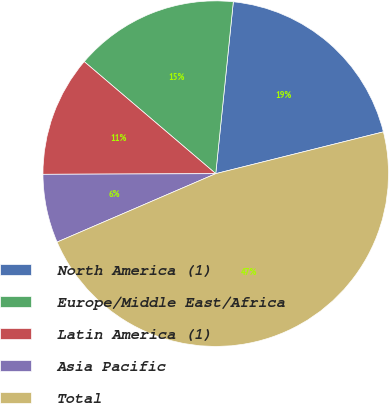Convert chart. <chart><loc_0><loc_0><loc_500><loc_500><pie_chart><fcel>North America (1)<fcel>Europe/Middle East/Africa<fcel>Latin America (1)<fcel>Asia Pacific<fcel>Total<nl><fcel>19.49%<fcel>15.39%<fcel>11.29%<fcel>6.42%<fcel>47.41%<nl></chart> 